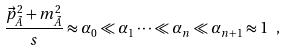Convert formula to latex. <formula><loc_0><loc_0><loc_500><loc_500>\frac { \vec { p } _ { \tilde { A } } ^ { 2 } + m _ { \tilde { A } } ^ { 2 } } { s } \approx \alpha _ { 0 } \ll \alpha _ { 1 } \dots \ll \alpha _ { n } \ll \alpha _ { n + 1 } \approx 1 \ ,</formula> 